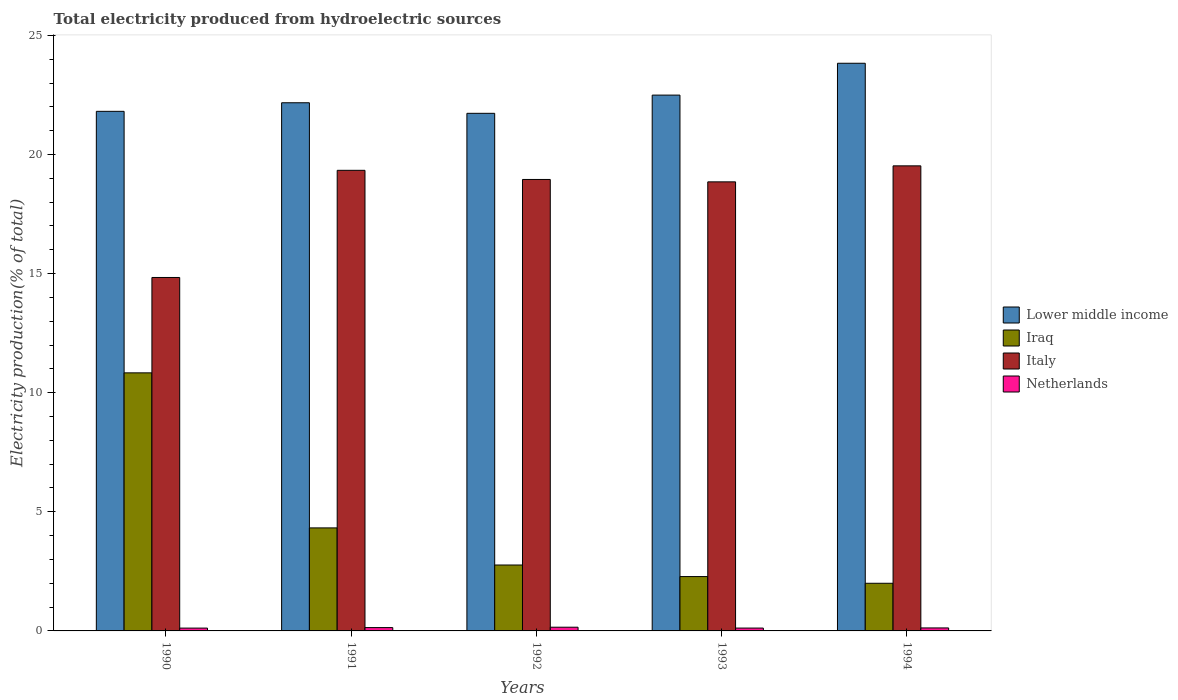How many different coloured bars are there?
Give a very brief answer. 4. Are the number of bars per tick equal to the number of legend labels?
Make the answer very short. Yes. What is the label of the 1st group of bars from the left?
Offer a very short reply. 1990. In how many cases, is the number of bars for a given year not equal to the number of legend labels?
Provide a succinct answer. 0. What is the total electricity produced in Iraq in 1993?
Ensure brevity in your answer.  2.28. Across all years, what is the maximum total electricity produced in Netherlands?
Your answer should be very brief. 0.16. What is the total total electricity produced in Lower middle income in the graph?
Offer a very short reply. 112.04. What is the difference between the total electricity produced in Lower middle income in 1990 and that in 1992?
Your response must be concise. 0.08. What is the difference between the total electricity produced in Lower middle income in 1992 and the total electricity produced in Netherlands in 1993?
Offer a very short reply. 21.61. What is the average total electricity produced in Netherlands per year?
Ensure brevity in your answer.  0.13. In the year 1994, what is the difference between the total electricity produced in Lower middle income and total electricity produced in Iraq?
Give a very brief answer. 21.83. In how many years, is the total electricity produced in Lower middle income greater than 5 %?
Provide a succinct answer. 5. What is the ratio of the total electricity produced in Iraq in 1990 to that in 1992?
Offer a very short reply. 3.92. What is the difference between the highest and the second highest total electricity produced in Lower middle income?
Your response must be concise. 1.34. What is the difference between the highest and the lowest total electricity produced in Iraq?
Offer a terse response. 8.83. In how many years, is the total electricity produced in Lower middle income greater than the average total electricity produced in Lower middle income taken over all years?
Your answer should be very brief. 2. Is the sum of the total electricity produced in Italy in 1991 and 1994 greater than the maximum total electricity produced in Netherlands across all years?
Your response must be concise. Yes. What does the 2nd bar from the right in 1994 represents?
Your answer should be compact. Italy. How many years are there in the graph?
Provide a succinct answer. 5. Are the values on the major ticks of Y-axis written in scientific E-notation?
Your answer should be compact. No. Does the graph contain grids?
Offer a very short reply. No. How many legend labels are there?
Provide a succinct answer. 4. How are the legend labels stacked?
Your response must be concise. Vertical. What is the title of the graph?
Your answer should be compact. Total electricity produced from hydroelectric sources. What is the label or title of the X-axis?
Your response must be concise. Years. What is the label or title of the Y-axis?
Your response must be concise. Electricity production(% of total). What is the Electricity production(% of total) of Lower middle income in 1990?
Your answer should be compact. 21.81. What is the Electricity production(% of total) in Iraq in 1990?
Provide a succinct answer. 10.83. What is the Electricity production(% of total) in Italy in 1990?
Make the answer very short. 14.84. What is the Electricity production(% of total) in Netherlands in 1990?
Keep it short and to the point. 0.12. What is the Electricity production(% of total) in Lower middle income in 1991?
Provide a short and direct response. 22.17. What is the Electricity production(% of total) in Iraq in 1991?
Provide a short and direct response. 4.32. What is the Electricity production(% of total) of Italy in 1991?
Your answer should be compact. 19.34. What is the Electricity production(% of total) in Netherlands in 1991?
Offer a terse response. 0.14. What is the Electricity production(% of total) in Lower middle income in 1992?
Provide a short and direct response. 21.73. What is the Electricity production(% of total) of Iraq in 1992?
Provide a succinct answer. 2.77. What is the Electricity production(% of total) in Italy in 1992?
Keep it short and to the point. 18.95. What is the Electricity production(% of total) of Netherlands in 1992?
Give a very brief answer. 0.16. What is the Electricity production(% of total) of Lower middle income in 1993?
Ensure brevity in your answer.  22.49. What is the Electricity production(% of total) in Iraq in 1993?
Keep it short and to the point. 2.28. What is the Electricity production(% of total) in Italy in 1993?
Your response must be concise. 18.85. What is the Electricity production(% of total) of Netherlands in 1993?
Your response must be concise. 0.12. What is the Electricity production(% of total) of Lower middle income in 1994?
Offer a very short reply. 23.83. What is the Electricity production(% of total) of Iraq in 1994?
Your response must be concise. 2. What is the Electricity production(% of total) of Italy in 1994?
Your answer should be very brief. 19.52. What is the Electricity production(% of total) in Netherlands in 1994?
Offer a very short reply. 0.13. Across all years, what is the maximum Electricity production(% of total) in Lower middle income?
Offer a very short reply. 23.83. Across all years, what is the maximum Electricity production(% of total) of Iraq?
Keep it short and to the point. 10.83. Across all years, what is the maximum Electricity production(% of total) of Italy?
Offer a very short reply. 19.52. Across all years, what is the maximum Electricity production(% of total) of Netherlands?
Offer a terse response. 0.16. Across all years, what is the minimum Electricity production(% of total) in Lower middle income?
Provide a succinct answer. 21.73. Across all years, what is the minimum Electricity production(% of total) of Italy?
Provide a succinct answer. 14.84. Across all years, what is the minimum Electricity production(% of total) of Netherlands?
Offer a very short reply. 0.12. What is the total Electricity production(% of total) of Lower middle income in the graph?
Make the answer very short. 112.04. What is the total Electricity production(% of total) in Iraq in the graph?
Make the answer very short. 22.21. What is the total Electricity production(% of total) of Italy in the graph?
Your answer should be compact. 91.5. What is the total Electricity production(% of total) in Netherlands in the graph?
Offer a terse response. 0.66. What is the difference between the Electricity production(% of total) of Lower middle income in 1990 and that in 1991?
Keep it short and to the point. -0.36. What is the difference between the Electricity production(% of total) of Iraq in 1990 and that in 1991?
Make the answer very short. 6.51. What is the difference between the Electricity production(% of total) of Italy in 1990 and that in 1991?
Provide a short and direct response. -4.5. What is the difference between the Electricity production(% of total) in Netherlands in 1990 and that in 1991?
Offer a very short reply. -0.02. What is the difference between the Electricity production(% of total) of Lower middle income in 1990 and that in 1992?
Give a very brief answer. 0.08. What is the difference between the Electricity production(% of total) of Iraq in 1990 and that in 1992?
Ensure brevity in your answer.  8.07. What is the difference between the Electricity production(% of total) of Italy in 1990 and that in 1992?
Make the answer very short. -4.11. What is the difference between the Electricity production(% of total) in Netherlands in 1990 and that in 1992?
Offer a terse response. -0.04. What is the difference between the Electricity production(% of total) of Lower middle income in 1990 and that in 1993?
Your answer should be very brief. -0.68. What is the difference between the Electricity production(% of total) in Iraq in 1990 and that in 1993?
Offer a very short reply. 8.55. What is the difference between the Electricity production(% of total) in Italy in 1990 and that in 1993?
Offer a terse response. -4.01. What is the difference between the Electricity production(% of total) in Netherlands in 1990 and that in 1993?
Offer a terse response. -0. What is the difference between the Electricity production(% of total) in Lower middle income in 1990 and that in 1994?
Provide a short and direct response. -2.02. What is the difference between the Electricity production(% of total) of Iraq in 1990 and that in 1994?
Offer a very short reply. 8.83. What is the difference between the Electricity production(% of total) of Italy in 1990 and that in 1994?
Offer a terse response. -4.69. What is the difference between the Electricity production(% of total) in Netherlands in 1990 and that in 1994?
Provide a short and direct response. -0.01. What is the difference between the Electricity production(% of total) of Lower middle income in 1991 and that in 1992?
Make the answer very short. 0.44. What is the difference between the Electricity production(% of total) of Iraq in 1991 and that in 1992?
Ensure brevity in your answer.  1.56. What is the difference between the Electricity production(% of total) in Italy in 1991 and that in 1992?
Ensure brevity in your answer.  0.38. What is the difference between the Electricity production(% of total) of Netherlands in 1991 and that in 1992?
Offer a very short reply. -0.02. What is the difference between the Electricity production(% of total) in Lower middle income in 1991 and that in 1993?
Your answer should be compact. -0.32. What is the difference between the Electricity production(% of total) of Iraq in 1991 and that in 1993?
Your answer should be compact. 2.04. What is the difference between the Electricity production(% of total) of Italy in 1991 and that in 1993?
Give a very brief answer. 0.48. What is the difference between the Electricity production(% of total) of Lower middle income in 1991 and that in 1994?
Provide a short and direct response. -1.66. What is the difference between the Electricity production(% of total) of Iraq in 1991 and that in 1994?
Keep it short and to the point. 2.32. What is the difference between the Electricity production(% of total) of Italy in 1991 and that in 1994?
Your response must be concise. -0.19. What is the difference between the Electricity production(% of total) of Netherlands in 1991 and that in 1994?
Ensure brevity in your answer.  0.01. What is the difference between the Electricity production(% of total) of Lower middle income in 1992 and that in 1993?
Your answer should be very brief. -0.76. What is the difference between the Electricity production(% of total) of Iraq in 1992 and that in 1993?
Make the answer very short. 0.49. What is the difference between the Electricity production(% of total) of Italy in 1992 and that in 1993?
Your answer should be very brief. 0.1. What is the difference between the Electricity production(% of total) in Netherlands in 1992 and that in 1993?
Keep it short and to the point. 0.04. What is the difference between the Electricity production(% of total) of Lower middle income in 1992 and that in 1994?
Offer a very short reply. -2.1. What is the difference between the Electricity production(% of total) in Iraq in 1992 and that in 1994?
Keep it short and to the point. 0.77. What is the difference between the Electricity production(% of total) in Italy in 1992 and that in 1994?
Offer a very short reply. -0.57. What is the difference between the Electricity production(% of total) in Lower middle income in 1993 and that in 1994?
Keep it short and to the point. -1.34. What is the difference between the Electricity production(% of total) of Iraq in 1993 and that in 1994?
Your answer should be compact. 0.28. What is the difference between the Electricity production(% of total) in Italy in 1993 and that in 1994?
Your response must be concise. -0.67. What is the difference between the Electricity production(% of total) of Netherlands in 1993 and that in 1994?
Provide a short and direct response. -0.01. What is the difference between the Electricity production(% of total) in Lower middle income in 1990 and the Electricity production(% of total) in Iraq in 1991?
Provide a short and direct response. 17.49. What is the difference between the Electricity production(% of total) of Lower middle income in 1990 and the Electricity production(% of total) of Italy in 1991?
Your answer should be compact. 2.48. What is the difference between the Electricity production(% of total) of Lower middle income in 1990 and the Electricity production(% of total) of Netherlands in 1991?
Offer a very short reply. 21.67. What is the difference between the Electricity production(% of total) in Iraq in 1990 and the Electricity production(% of total) in Italy in 1991?
Keep it short and to the point. -8.5. What is the difference between the Electricity production(% of total) of Iraq in 1990 and the Electricity production(% of total) of Netherlands in 1991?
Give a very brief answer. 10.69. What is the difference between the Electricity production(% of total) in Italy in 1990 and the Electricity production(% of total) in Netherlands in 1991?
Keep it short and to the point. 14.7. What is the difference between the Electricity production(% of total) in Lower middle income in 1990 and the Electricity production(% of total) in Iraq in 1992?
Keep it short and to the point. 19.05. What is the difference between the Electricity production(% of total) in Lower middle income in 1990 and the Electricity production(% of total) in Italy in 1992?
Your answer should be compact. 2.86. What is the difference between the Electricity production(% of total) in Lower middle income in 1990 and the Electricity production(% of total) in Netherlands in 1992?
Keep it short and to the point. 21.66. What is the difference between the Electricity production(% of total) in Iraq in 1990 and the Electricity production(% of total) in Italy in 1992?
Provide a succinct answer. -8.12. What is the difference between the Electricity production(% of total) in Iraq in 1990 and the Electricity production(% of total) in Netherlands in 1992?
Ensure brevity in your answer.  10.68. What is the difference between the Electricity production(% of total) of Italy in 1990 and the Electricity production(% of total) of Netherlands in 1992?
Provide a short and direct response. 14.68. What is the difference between the Electricity production(% of total) of Lower middle income in 1990 and the Electricity production(% of total) of Iraq in 1993?
Ensure brevity in your answer.  19.53. What is the difference between the Electricity production(% of total) of Lower middle income in 1990 and the Electricity production(% of total) of Italy in 1993?
Your answer should be very brief. 2.96. What is the difference between the Electricity production(% of total) in Lower middle income in 1990 and the Electricity production(% of total) in Netherlands in 1993?
Provide a short and direct response. 21.69. What is the difference between the Electricity production(% of total) of Iraq in 1990 and the Electricity production(% of total) of Italy in 1993?
Give a very brief answer. -8.02. What is the difference between the Electricity production(% of total) of Iraq in 1990 and the Electricity production(% of total) of Netherlands in 1993?
Provide a short and direct response. 10.71. What is the difference between the Electricity production(% of total) in Italy in 1990 and the Electricity production(% of total) in Netherlands in 1993?
Ensure brevity in your answer.  14.72. What is the difference between the Electricity production(% of total) of Lower middle income in 1990 and the Electricity production(% of total) of Iraq in 1994?
Give a very brief answer. 19.81. What is the difference between the Electricity production(% of total) in Lower middle income in 1990 and the Electricity production(% of total) in Italy in 1994?
Ensure brevity in your answer.  2.29. What is the difference between the Electricity production(% of total) of Lower middle income in 1990 and the Electricity production(% of total) of Netherlands in 1994?
Offer a very short reply. 21.69. What is the difference between the Electricity production(% of total) in Iraq in 1990 and the Electricity production(% of total) in Italy in 1994?
Keep it short and to the point. -8.69. What is the difference between the Electricity production(% of total) of Iraq in 1990 and the Electricity production(% of total) of Netherlands in 1994?
Ensure brevity in your answer.  10.71. What is the difference between the Electricity production(% of total) in Italy in 1990 and the Electricity production(% of total) in Netherlands in 1994?
Offer a terse response. 14.71. What is the difference between the Electricity production(% of total) of Lower middle income in 1991 and the Electricity production(% of total) of Iraq in 1992?
Give a very brief answer. 19.4. What is the difference between the Electricity production(% of total) of Lower middle income in 1991 and the Electricity production(% of total) of Italy in 1992?
Provide a succinct answer. 3.22. What is the difference between the Electricity production(% of total) of Lower middle income in 1991 and the Electricity production(% of total) of Netherlands in 1992?
Provide a short and direct response. 22.02. What is the difference between the Electricity production(% of total) of Iraq in 1991 and the Electricity production(% of total) of Italy in 1992?
Provide a succinct answer. -14.63. What is the difference between the Electricity production(% of total) of Iraq in 1991 and the Electricity production(% of total) of Netherlands in 1992?
Provide a short and direct response. 4.17. What is the difference between the Electricity production(% of total) of Italy in 1991 and the Electricity production(% of total) of Netherlands in 1992?
Your answer should be compact. 19.18. What is the difference between the Electricity production(% of total) of Lower middle income in 1991 and the Electricity production(% of total) of Iraq in 1993?
Your answer should be very brief. 19.89. What is the difference between the Electricity production(% of total) of Lower middle income in 1991 and the Electricity production(% of total) of Italy in 1993?
Your answer should be very brief. 3.32. What is the difference between the Electricity production(% of total) in Lower middle income in 1991 and the Electricity production(% of total) in Netherlands in 1993?
Your response must be concise. 22.05. What is the difference between the Electricity production(% of total) in Iraq in 1991 and the Electricity production(% of total) in Italy in 1993?
Provide a succinct answer. -14.53. What is the difference between the Electricity production(% of total) of Iraq in 1991 and the Electricity production(% of total) of Netherlands in 1993?
Offer a terse response. 4.21. What is the difference between the Electricity production(% of total) of Italy in 1991 and the Electricity production(% of total) of Netherlands in 1993?
Offer a terse response. 19.22. What is the difference between the Electricity production(% of total) of Lower middle income in 1991 and the Electricity production(% of total) of Iraq in 1994?
Offer a terse response. 20.17. What is the difference between the Electricity production(% of total) of Lower middle income in 1991 and the Electricity production(% of total) of Italy in 1994?
Your response must be concise. 2.65. What is the difference between the Electricity production(% of total) of Lower middle income in 1991 and the Electricity production(% of total) of Netherlands in 1994?
Keep it short and to the point. 22.05. What is the difference between the Electricity production(% of total) in Iraq in 1991 and the Electricity production(% of total) in Italy in 1994?
Provide a short and direct response. -15.2. What is the difference between the Electricity production(% of total) of Iraq in 1991 and the Electricity production(% of total) of Netherlands in 1994?
Provide a succinct answer. 4.2. What is the difference between the Electricity production(% of total) of Italy in 1991 and the Electricity production(% of total) of Netherlands in 1994?
Your answer should be very brief. 19.21. What is the difference between the Electricity production(% of total) of Lower middle income in 1992 and the Electricity production(% of total) of Iraq in 1993?
Make the answer very short. 19.45. What is the difference between the Electricity production(% of total) in Lower middle income in 1992 and the Electricity production(% of total) in Italy in 1993?
Your answer should be very brief. 2.88. What is the difference between the Electricity production(% of total) of Lower middle income in 1992 and the Electricity production(% of total) of Netherlands in 1993?
Make the answer very short. 21.61. What is the difference between the Electricity production(% of total) in Iraq in 1992 and the Electricity production(% of total) in Italy in 1993?
Your answer should be very brief. -16.08. What is the difference between the Electricity production(% of total) in Iraq in 1992 and the Electricity production(% of total) in Netherlands in 1993?
Offer a very short reply. 2.65. What is the difference between the Electricity production(% of total) of Italy in 1992 and the Electricity production(% of total) of Netherlands in 1993?
Provide a short and direct response. 18.83. What is the difference between the Electricity production(% of total) of Lower middle income in 1992 and the Electricity production(% of total) of Iraq in 1994?
Ensure brevity in your answer.  19.73. What is the difference between the Electricity production(% of total) of Lower middle income in 1992 and the Electricity production(% of total) of Italy in 1994?
Make the answer very short. 2.21. What is the difference between the Electricity production(% of total) in Lower middle income in 1992 and the Electricity production(% of total) in Netherlands in 1994?
Offer a very short reply. 21.6. What is the difference between the Electricity production(% of total) of Iraq in 1992 and the Electricity production(% of total) of Italy in 1994?
Offer a very short reply. -16.76. What is the difference between the Electricity production(% of total) in Iraq in 1992 and the Electricity production(% of total) in Netherlands in 1994?
Give a very brief answer. 2.64. What is the difference between the Electricity production(% of total) in Italy in 1992 and the Electricity production(% of total) in Netherlands in 1994?
Provide a succinct answer. 18.83. What is the difference between the Electricity production(% of total) of Lower middle income in 1993 and the Electricity production(% of total) of Iraq in 1994?
Provide a succinct answer. 20.49. What is the difference between the Electricity production(% of total) in Lower middle income in 1993 and the Electricity production(% of total) in Italy in 1994?
Provide a succinct answer. 2.97. What is the difference between the Electricity production(% of total) in Lower middle income in 1993 and the Electricity production(% of total) in Netherlands in 1994?
Your response must be concise. 22.37. What is the difference between the Electricity production(% of total) of Iraq in 1993 and the Electricity production(% of total) of Italy in 1994?
Make the answer very short. -17.24. What is the difference between the Electricity production(% of total) of Iraq in 1993 and the Electricity production(% of total) of Netherlands in 1994?
Give a very brief answer. 2.16. What is the difference between the Electricity production(% of total) in Italy in 1993 and the Electricity production(% of total) in Netherlands in 1994?
Offer a terse response. 18.73. What is the average Electricity production(% of total) of Lower middle income per year?
Provide a succinct answer. 22.41. What is the average Electricity production(% of total) of Iraq per year?
Ensure brevity in your answer.  4.44. What is the average Electricity production(% of total) in Italy per year?
Offer a terse response. 18.3. What is the average Electricity production(% of total) in Netherlands per year?
Offer a terse response. 0.13. In the year 1990, what is the difference between the Electricity production(% of total) of Lower middle income and Electricity production(% of total) of Iraq?
Provide a short and direct response. 10.98. In the year 1990, what is the difference between the Electricity production(% of total) of Lower middle income and Electricity production(% of total) of Italy?
Your answer should be compact. 6.97. In the year 1990, what is the difference between the Electricity production(% of total) of Lower middle income and Electricity production(% of total) of Netherlands?
Make the answer very short. 21.69. In the year 1990, what is the difference between the Electricity production(% of total) of Iraq and Electricity production(% of total) of Italy?
Give a very brief answer. -4. In the year 1990, what is the difference between the Electricity production(% of total) of Iraq and Electricity production(% of total) of Netherlands?
Offer a very short reply. 10.72. In the year 1990, what is the difference between the Electricity production(% of total) in Italy and Electricity production(% of total) in Netherlands?
Provide a short and direct response. 14.72. In the year 1991, what is the difference between the Electricity production(% of total) in Lower middle income and Electricity production(% of total) in Iraq?
Offer a terse response. 17.85. In the year 1991, what is the difference between the Electricity production(% of total) in Lower middle income and Electricity production(% of total) in Italy?
Ensure brevity in your answer.  2.84. In the year 1991, what is the difference between the Electricity production(% of total) in Lower middle income and Electricity production(% of total) in Netherlands?
Give a very brief answer. 22.03. In the year 1991, what is the difference between the Electricity production(% of total) of Iraq and Electricity production(% of total) of Italy?
Ensure brevity in your answer.  -15.01. In the year 1991, what is the difference between the Electricity production(% of total) in Iraq and Electricity production(% of total) in Netherlands?
Offer a very short reply. 4.19. In the year 1991, what is the difference between the Electricity production(% of total) in Italy and Electricity production(% of total) in Netherlands?
Provide a short and direct response. 19.2. In the year 1992, what is the difference between the Electricity production(% of total) in Lower middle income and Electricity production(% of total) in Iraq?
Provide a succinct answer. 18.96. In the year 1992, what is the difference between the Electricity production(% of total) of Lower middle income and Electricity production(% of total) of Italy?
Offer a very short reply. 2.78. In the year 1992, what is the difference between the Electricity production(% of total) of Lower middle income and Electricity production(% of total) of Netherlands?
Your response must be concise. 21.57. In the year 1992, what is the difference between the Electricity production(% of total) in Iraq and Electricity production(% of total) in Italy?
Offer a terse response. -16.19. In the year 1992, what is the difference between the Electricity production(% of total) in Iraq and Electricity production(% of total) in Netherlands?
Offer a very short reply. 2.61. In the year 1992, what is the difference between the Electricity production(% of total) in Italy and Electricity production(% of total) in Netherlands?
Offer a terse response. 18.8. In the year 1993, what is the difference between the Electricity production(% of total) in Lower middle income and Electricity production(% of total) in Iraq?
Ensure brevity in your answer.  20.21. In the year 1993, what is the difference between the Electricity production(% of total) of Lower middle income and Electricity production(% of total) of Italy?
Your answer should be very brief. 3.64. In the year 1993, what is the difference between the Electricity production(% of total) of Lower middle income and Electricity production(% of total) of Netherlands?
Offer a very short reply. 22.37. In the year 1993, what is the difference between the Electricity production(% of total) of Iraq and Electricity production(% of total) of Italy?
Offer a very short reply. -16.57. In the year 1993, what is the difference between the Electricity production(% of total) of Iraq and Electricity production(% of total) of Netherlands?
Your answer should be compact. 2.16. In the year 1993, what is the difference between the Electricity production(% of total) of Italy and Electricity production(% of total) of Netherlands?
Offer a very short reply. 18.73. In the year 1994, what is the difference between the Electricity production(% of total) of Lower middle income and Electricity production(% of total) of Iraq?
Provide a short and direct response. 21.83. In the year 1994, what is the difference between the Electricity production(% of total) of Lower middle income and Electricity production(% of total) of Italy?
Your answer should be compact. 4.31. In the year 1994, what is the difference between the Electricity production(% of total) of Lower middle income and Electricity production(% of total) of Netherlands?
Ensure brevity in your answer.  23.7. In the year 1994, what is the difference between the Electricity production(% of total) in Iraq and Electricity production(% of total) in Italy?
Make the answer very short. -17.52. In the year 1994, what is the difference between the Electricity production(% of total) of Iraq and Electricity production(% of total) of Netherlands?
Your response must be concise. 1.87. In the year 1994, what is the difference between the Electricity production(% of total) in Italy and Electricity production(% of total) in Netherlands?
Make the answer very short. 19.4. What is the ratio of the Electricity production(% of total) in Lower middle income in 1990 to that in 1991?
Ensure brevity in your answer.  0.98. What is the ratio of the Electricity production(% of total) of Iraq in 1990 to that in 1991?
Your response must be concise. 2.5. What is the ratio of the Electricity production(% of total) in Italy in 1990 to that in 1991?
Provide a succinct answer. 0.77. What is the ratio of the Electricity production(% of total) in Netherlands in 1990 to that in 1991?
Provide a short and direct response. 0.85. What is the ratio of the Electricity production(% of total) in Iraq in 1990 to that in 1992?
Provide a short and direct response. 3.92. What is the ratio of the Electricity production(% of total) of Italy in 1990 to that in 1992?
Keep it short and to the point. 0.78. What is the ratio of the Electricity production(% of total) of Netherlands in 1990 to that in 1992?
Offer a very short reply. 0.76. What is the ratio of the Electricity production(% of total) in Lower middle income in 1990 to that in 1993?
Give a very brief answer. 0.97. What is the ratio of the Electricity production(% of total) in Iraq in 1990 to that in 1993?
Your answer should be very brief. 4.75. What is the ratio of the Electricity production(% of total) of Italy in 1990 to that in 1993?
Your response must be concise. 0.79. What is the ratio of the Electricity production(% of total) of Netherlands in 1990 to that in 1993?
Your answer should be very brief. 0.99. What is the ratio of the Electricity production(% of total) of Lower middle income in 1990 to that in 1994?
Your response must be concise. 0.92. What is the ratio of the Electricity production(% of total) of Iraq in 1990 to that in 1994?
Give a very brief answer. 5.42. What is the ratio of the Electricity production(% of total) in Italy in 1990 to that in 1994?
Keep it short and to the point. 0.76. What is the ratio of the Electricity production(% of total) in Netherlands in 1990 to that in 1994?
Your answer should be compact. 0.94. What is the ratio of the Electricity production(% of total) of Lower middle income in 1991 to that in 1992?
Give a very brief answer. 1.02. What is the ratio of the Electricity production(% of total) of Iraq in 1991 to that in 1992?
Make the answer very short. 1.56. What is the ratio of the Electricity production(% of total) in Italy in 1991 to that in 1992?
Make the answer very short. 1.02. What is the ratio of the Electricity production(% of total) of Netherlands in 1991 to that in 1992?
Provide a short and direct response. 0.9. What is the ratio of the Electricity production(% of total) of Lower middle income in 1991 to that in 1993?
Your answer should be very brief. 0.99. What is the ratio of the Electricity production(% of total) in Iraq in 1991 to that in 1993?
Provide a succinct answer. 1.9. What is the ratio of the Electricity production(% of total) in Italy in 1991 to that in 1993?
Give a very brief answer. 1.03. What is the ratio of the Electricity production(% of total) in Netherlands in 1991 to that in 1993?
Give a very brief answer. 1.17. What is the ratio of the Electricity production(% of total) in Lower middle income in 1991 to that in 1994?
Provide a succinct answer. 0.93. What is the ratio of the Electricity production(% of total) in Iraq in 1991 to that in 1994?
Ensure brevity in your answer.  2.16. What is the ratio of the Electricity production(% of total) in Italy in 1991 to that in 1994?
Offer a terse response. 0.99. What is the ratio of the Electricity production(% of total) of Netherlands in 1991 to that in 1994?
Your answer should be compact. 1.11. What is the ratio of the Electricity production(% of total) of Lower middle income in 1992 to that in 1993?
Offer a very short reply. 0.97. What is the ratio of the Electricity production(% of total) of Iraq in 1992 to that in 1993?
Ensure brevity in your answer.  1.21. What is the ratio of the Electricity production(% of total) of Italy in 1992 to that in 1993?
Provide a short and direct response. 1.01. What is the ratio of the Electricity production(% of total) in Netherlands in 1992 to that in 1993?
Your answer should be compact. 1.3. What is the ratio of the Electricity production(% of total) of Lower middle income in 1992 to that in 1994?
Make the answer very short. 0.91. What is the ratio of the Electricity production(% of total) in Iraq in 1992 to that in 1994?
Make the answer very short. 1.38. What is the ratio of the Electricity production(% of total) in Italy in 1992 to that in 1994?
Give a very brief answer. 0.97. What is the ratio of the Electricity production(% of total) of Netherlands in 1992 to that in 1994?
Offer a terse response. 1.24. What is the ratio of the Electricity production(% of total) in Lower middle income in 1993 to that in 1994?
Provide a short and direct response. 0.94. What is the ratio of the Electricity production(% of total) of Iraq in 1993 to that in 1994?
Offer a very short reply. 1.14. What is the ratio of the Electricity production(% of total) in Italy in 1993 to that in 1994?
Offer a terse response. 0.97. What is the ratio of the Electricity production(% of total) of Netherlands in 1993 to that in 1994?
Your answer should be very brief. 0.95. What is the difference between the highest and the second highest Electricity production(% of total) of Lower middle income?
Offer a very short reply. 1.34. What is the difference between the highest and the second highest Electricity production(% of total) of Iraq?
Give a very brief answer. 6.51. What is the difference between the highest and the second highest Electricity production(% of total) in Italy?
Provide a short and direct response. 0.19. What is the difference between the highest and the second highest Electricity production(% of total) in Netherlands?
Provide a short and direct response. 0.02. What is the difference between the highest and the lowest Electricity production(% of total) in Lower middle income?
Provide a short and direct response. 2.1. What is the difference between the highest and the lowest Electricity production(% of total) in Iraq?
Ensure brevity in your answer.  8.83. What is the difference between the highest and the lowest Electricity production(% of total) of Italy?
Make the answer very short. 4.69. What is the difference between the highest and the lowest Electricity production(% of total) of Netherlands?
Offer a very short reply. 0.04. 